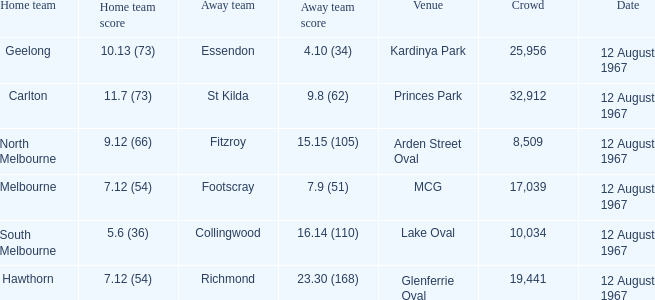What is the date of the game between Melbourne and Footscray? 12 August 1967. 